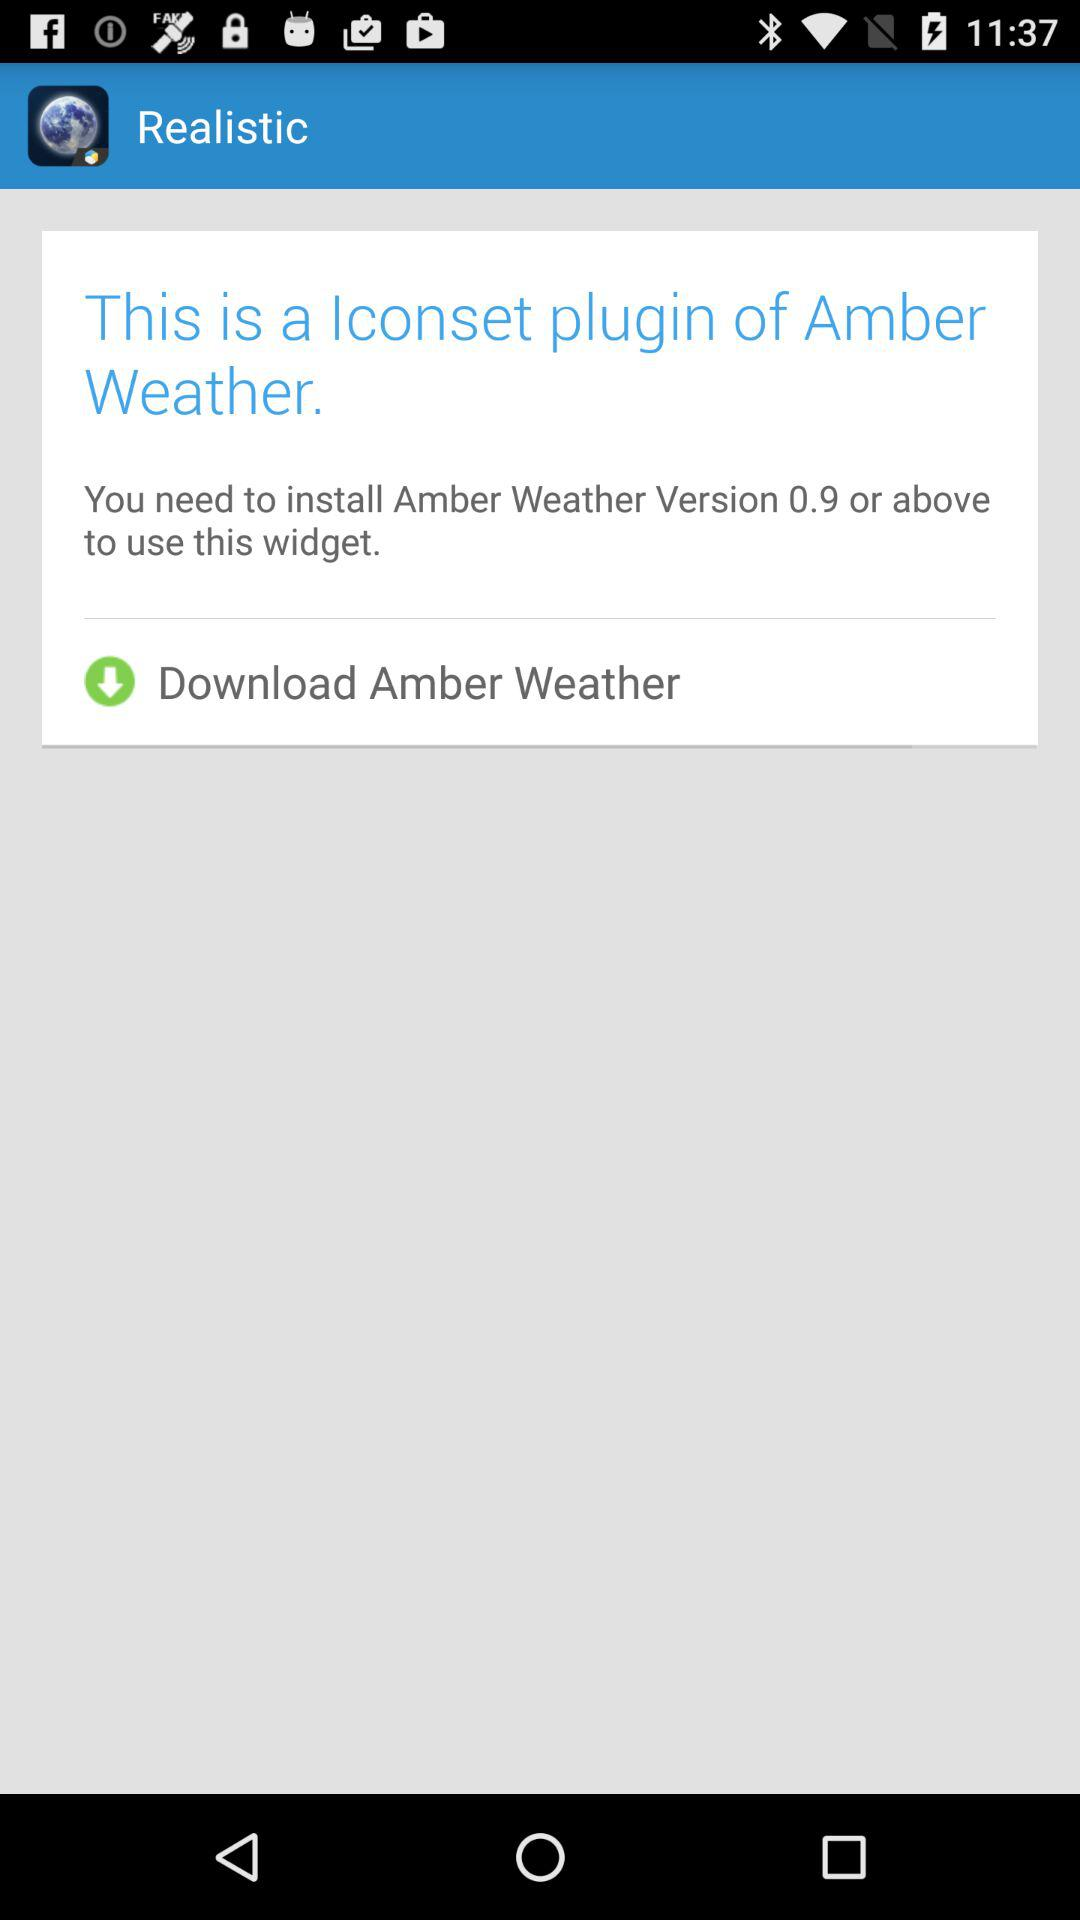What application do I need to install? You need to install the "Amber Weather" application. 